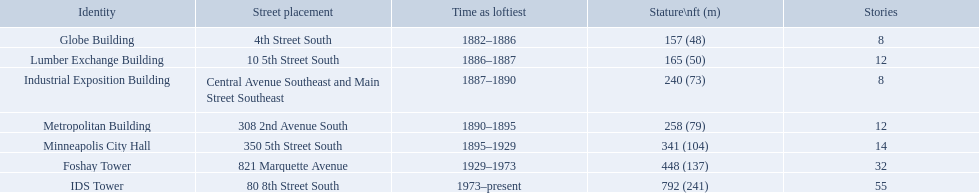What are the heights of the buildings? 157 (48), 165 (50), 240 (73), 258 (79), 341 (104), 448 (137), 792 (241). What building is 240 ft tall? Industrial Exposition Building. Would you mind parsing the complete table? {'header': ['Identity', 'Street placement', 'Time as loftiest', 'Stature\\nft (m)', 'Stories'], 'rows': [['Globe Building', '4th Street South', '1882–1886', '157 (48)', '8'], ['Lumber Exchange Building', '10 5th Street South', '1886–1887', '165 (50)', '12'], ['Industrial Exposition Building', 'Central Avenue Southeast and Main Street Southeast', '1887–1890', '240 (73)', '8'], ['Metropolitan Building', '308 2nd Avenue South', '1890–1895', '258 (79)', '12'], ['Minneapolis City Hall', '350 5th Street South', '1895–1929', '341 (104)', '14'], ['Foshay Tower', '821 Marquette Avenue', '1929–1973', '448 (137)', '32'], ['IDS Tower', '80 8th Street South', '1973–present', '792 (241)', '55']]} What are the tallest buildings in minneapolis? Globe Building, Lumber Exchange Building, Industrial Exposition Building, Metropolitan Building, Minneapolis City Hall, Foshay Tower, IDS Tower. What is the height of the metropolitan building? 258 (79). What is the height of the lumber exchange building? 165 (50). Of those two which is taller? Metropolitan Building. How tall is the metropolitan building? 258 (79). How tall is the lumber exchange building? 165 (50). Is the metropolitan or lumber exchange building taller? Metropolitan Building. 